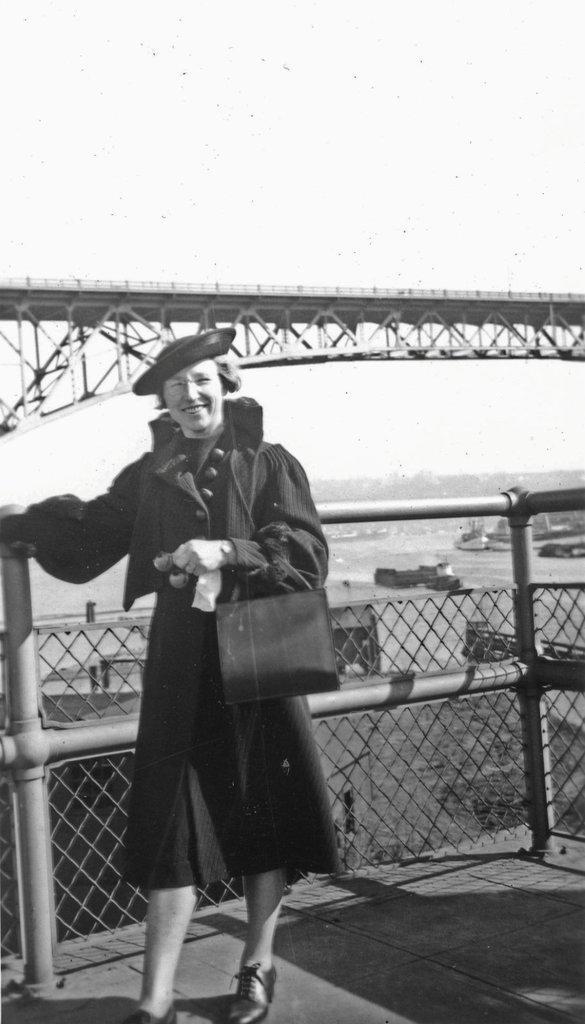In one or two sentences, can you explain what this image depicts? This is a black and white picture. Here we can see a woman. She is smiling and she wore a hat. In the background we can see a fence, boats, water, and sky. 